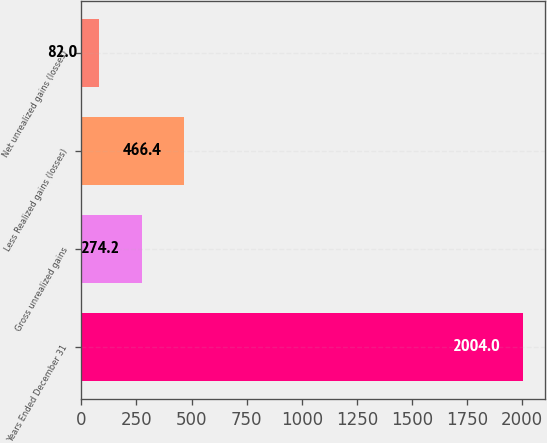<chart> <loc_0><loc_0><loc_500><loc_500><bar_chart><fcel>Years Ended December 31<fcel>Gross unrealized gains<fcel>Less Realized gains (losses)<fcel>Net unrealized gains (losses)<nl><fcel>2004<fcel>274.2<fcel>466.4<fcel>82<nl></chart> 